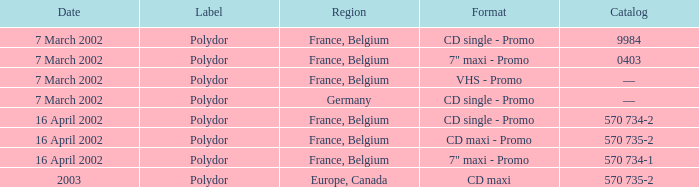I'm looking to parse the entire table for insights. Could you assist me with that? {'header': ['Date', 'Label', 'Region', 'Format', 'Catalog'], 'rows': [['7 March 2002', 'Polydor', 'France, Belgium', 'CD single - Promo', '9984'], ['7 March 2002', 'Polydor', 'France, Belgium', '7" maxi - Promo', '0403'], ['7 March 2002', 'Polydor', 'France, Belgium', 'VHS - Promo', '—'], ['7 March 2002', 'Polydor', 'Germany', 'CD single - Promo', '—'], ['16 April 2002', 'Polydor', 'France, Belgium', 'CD single - Promo', '570 734-2'], ['16 April 2002', 'Polydor', 'France, Belgium', 'CD maxi - Promo', '570 735-2'], ['16 April 2002', 'Polydor', 'France, Belgium', '7" maxi - Promo', '570 734-1'], ['2003', 'Polydor', 'Europe, Canada', 'CD maxi', '570 735-2']]} Which region had a release format of CD Maxi? Europe, Canada. 